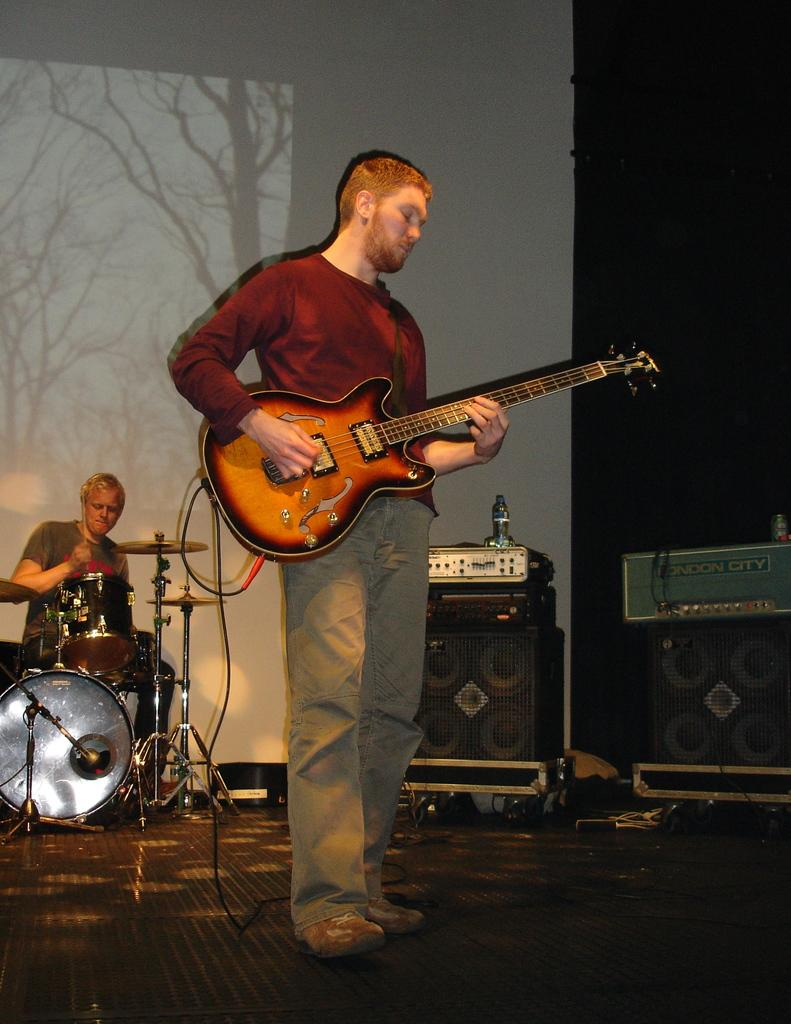What is the main subject of the image? There is a man standing in the middle of the image. What is the man in the middle doing? The man in the middle is playing a guitar. What is the man on the left side of the image doing? The man on the left is beating drums. What can be seen on the right side of the image? There are speakers visible on the right side of the image. How many boys are present in the image? There is no boy present in the image; both men are adults. Can you tell me how the guitar moves in the image? The guitar does not move in the image; it is being played by the man standing in the middle. 